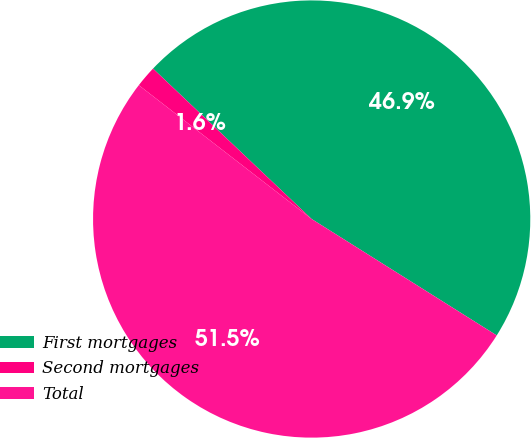<chart> <loc_0><loc_0><loc_500><loc_500><pie_chart><fcel>First mortgages<fcel>Second mortgages<fcel>Total<nl><fcel>46.86%<fcel>1.59%<fcel>51.55%<nl></chart> 